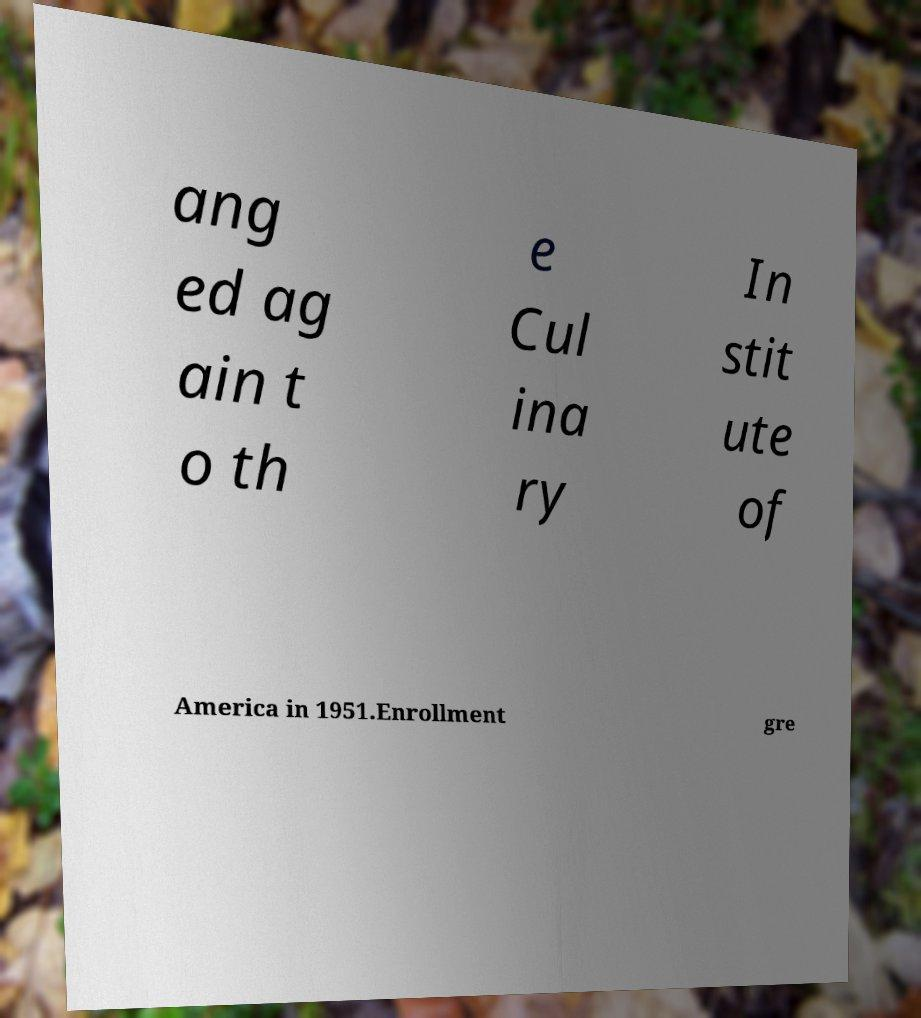There's text embedded in this image that I need extracted. Can you transcribe it verbatim? ang ed ag ain t o th e Cul ina ry In stit ute of America in 1951.Enrollment gre 